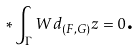<formula> <loc_0><loc_0><loc_500><loc_500>\ast \int _ { \Gamma } W d _ { ( F , G ) } z = 0 \text {.}</formula> 